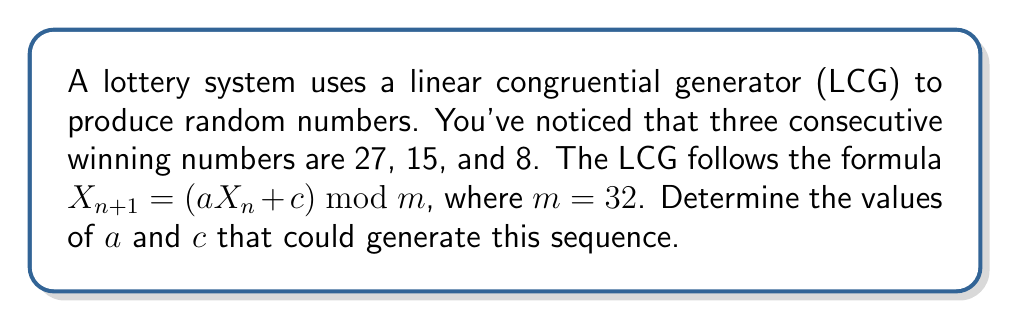What is the answer to this math problem? Let's approach this step-by-step:

1) We know that $X_1 = 27$, $X_2 = 15$, and $X_3 = 8$.

2) Using the LCG formula, we can write two equations:
   $15 = (a \cdot 27 + c) \bmod 32$
   $8 = (a \cdot 15 + c) \bmod 32$

3) These can be rewritten as:
   $15 = a \cdot 27 + c - 32k$ for some integer $k$
   $8 = a \cdot 15 + c - 32l$ for some integer $l$

4) Subtracting the second equation from the first:
   $7 = a \cdot 12 - 32(k-l)$

5) This means $a \cdot 12$ must be congruent to 7 modulo 32.

6) Testing values, we find that $a = 23$ satisfies this condition:
   $23 \cdot 12 = 276 \equiv 7 \pmod{32}$

7) Now that we know $a$, we can substitute back into either of the original equations to find $c$:
   $15 = (23 \cdot 27 + c) \bmod 32$
   $15 = (621 + c) \bmod 32$
   $15 = (13 + c) \bmod 32$

8) Solving this, we get $c = 2$.

9) We can verify:
   $(23 \cdot 27 + 2) \bmod 32 = 623 \bmod 32 = 15$
   $(23 \cdot 15 + 2) \bmod 32 = 347 \bmod 32 = 8$

Therefore, $a = 23$ and $c = 2$ are values that could generate this sequence.
Answer: $a = 23$, $c = 2$ 